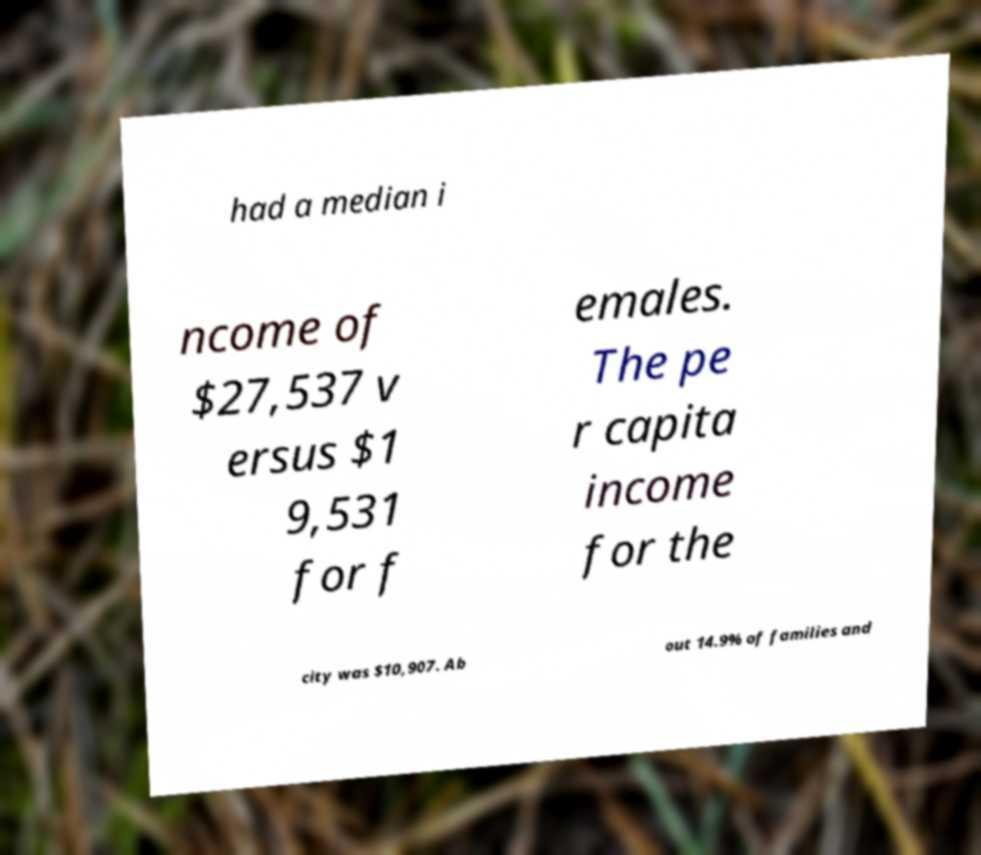There's text embedded in this image that I need extracted. Can you transcribe it verbatim? had a median i ncome of $27,537 v ersus $1 9,531 for f emales. The pe r capita income for the city was $10,907. Ab out 14.9% of families and 